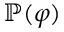<formula> <loc_0><loc_0><loc_500><loc_500>\mathbb { P } ( \varphi )</formula> 